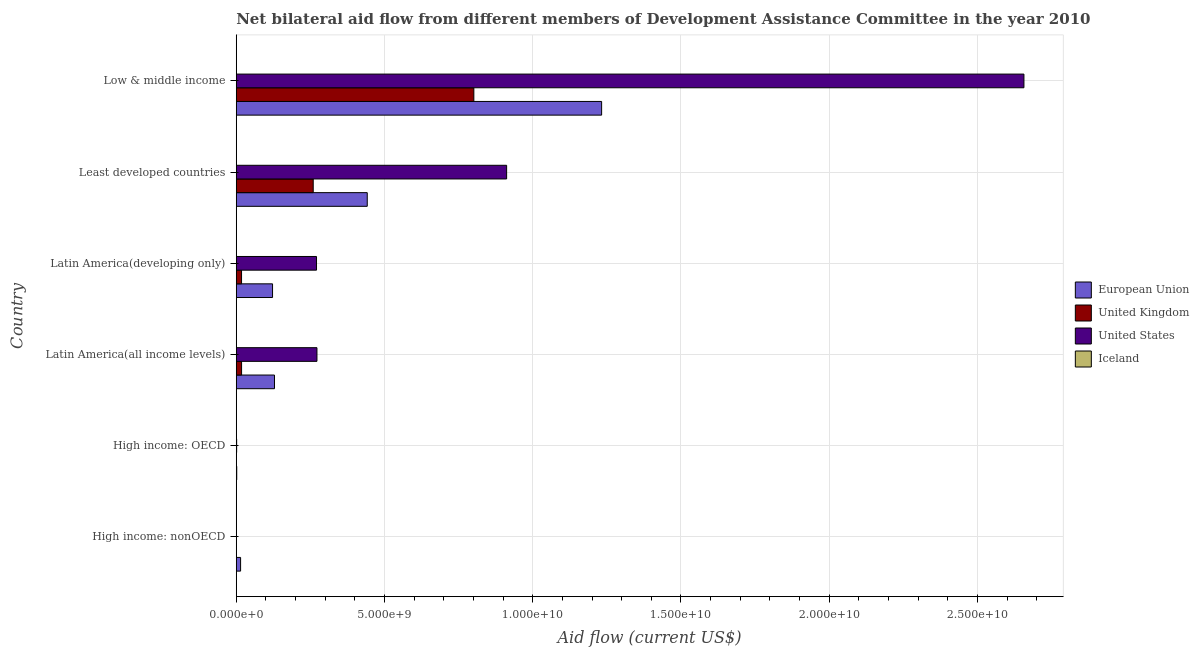How many bars are there on the 2nd tick from the top?
Your answer should be compact. 4. What is the label of the 6th group of bars from the top?
Your answer should be very brief. High income: nonOECD. In how many cases, is the number of bars for a given country not equal to the number of legend labels?
Your answer should be very brief. 0. What is the amount of aid given by us in Least developed countries?
Offer a very short reply. 9.12e+09. Across all countries, what is the maximum amount of aid given by eu?
Keep it short and to the point. 1.23e+1. Across all countries, what is the minimum amount of aid given by uk?
Provide a succinct answer. 6.60e+05. In which country was the amount of aid given by iceland minimum?
Ensure brevity in your answer.  High income: nonOECD. What is the total amount of aid given by eu in the graph?
Your answer should be very brief. 1.94e+1. What is the difference between the amount of aid given by us in High income: nonOECD and that in Low & middle income?
Your answer should be very brief. -2.66e+1. What is the difference between the amount of aid given by eu in Least developed countries and the amount of aid given by us in Latin America(developing only)?
Offer a very short reply. 1.71e+09. What is the average amount of aid given by iceland per country?
Offer a terse response. 2.26e+06. What is the difference between the amount of aid given by iceland and amount of aid given by us in High income: OECD?
Provide a succinct answer. -1.22e+07. What is the ratio of the amount of aid given by iceland in Latin America(developing only) to that in Low & middle income?
Provide a succinct answer. 1.64. Is the difference between the amount of aid given by uk in High income: nonOECD and Least developed countries greater than the difference between the amount of aid given by iceland in High income: nonOECD and Least developed countries?
Give a very brief answer. No. What is the difference between the highest and the second highest amount of aid given by eu?
Your response must be concise. 7.91e+09. What is the difference between the highest and the lowest amount of aid given by us?
Offer a very short reply. 2.66e+1. In how many countries, is the amount of aid given by us greater than the average amount of aid given by us taken over all countries?
Offer a terse response. 2. Is the sum of the amount of aid given by eu in Least developed countries and Low & middle income greater than the maximum amount of aid given by us across all countries?
Offer a terse response. No. Is it the case that in every country, the sum of the amount of aid given by eu and amount of aid given by us is greater than the sum of amount of aid given by iceland and amount of aid given by uk?
Make the answer very short. Yes. What does the 1st bar from the bottom in Low & middle income represents?
Give a very brief answer. European Union. How many bars are there?
Give a very brief answer. 24. How many countries are there in the graph?
Your answer should be compact. 6. Are the values on the major ticks of X-axis written in scientific E-notation?
Your answer should be compact. Yes. Does the graph contain grids?
Make the answer very short. Yes. How many legend labels are there?
Provide a short and direct response. 4. How are the legend labels stacked?
Provide a short and direct response. Vertical. What is the title of the graph?
Give a very brief answer. Net bilateral aid flow from different members of Development Assistance Committee in the year 2010. Does "Methodology assessment" appear as one of the legend labels in the graph?
Provide a short and direct response. No. What is the label or title of the X-axis?
Your answer should be compact. Aid flow (current US$). What is the label or title of the Y-axis?
Give a very brief answer. Country. What is the Aid flow (current US$) of European Union in High income: nonOECD?
Your answer should be very brief. 1.46e+08. What is the Aid flow (current US$) in United Kingdom in High income: nonOECD?
Provide a short and direct response. 2.37e+06. What is the Aid flow (current US$) of United States in High income: nonOECD?
Make the answer very short. 5.04e+06. What is the Aid flow (current US$) of Iceland in High income: nonOECD?
Keep it short and to the point. 1.05e+06. What is the Aid flow (current US$) in European Union in High income: OECD?
Your response must be concise. 1.62e+07. What is the Aid flow (current US$) of United Kingdom in High income: OECD?
Keep it short and to the point. 6.60e+05. What is the Aid flow (current US$) of United States in High income: OECD?
Give a very brief answer. 1.32e+07. What is the Aid flow (current US$) of Iceland in High income: OECD?
Your answer should be very brief. 1.05e+06. What is the Aid flow (current US$) in European Union in Latin America(all income levels)?
Offer a very short reply. 1.29e+09. What is the Aid flow (current US$) of United Kingdom in Latin America(all income levels)?
Ensure brevity in your answer.  1.80e+08. What is the Aid flow (current US$) of United States in Latin America(all income levels)?
Your answer should be very brief. 2.72e+09. What is the Aid flow (current US$) in Iceland in Latin America(all income levels)?
Ensure brevity in your answer.  4.75e+06. What is the Aid flow (current US$) in European Union in Latin America(developing only)?
Provide a succinct answer. 1.22e+09. What is the Aid flow (current US$) of United Kingdom in Latin America(developing only)?
Provide a short and direct response. 1.78e+08. What is the Aid flow (current US$) of United States in Latin America(developing only)?
Keep it short and to the point. 2.71e+09. What is the Aid flow (current US$) in Iceland in Latin America(developing only)?
Keep it short and to the point. 2.57e+06. What is the Aid flow (current US$) in European Union in Least developed countries?
Your answer should be compact. 4.42e+09. What is the Aid flow (current US$) of United Kingdom in Least developed countries?
Provide a short and direct response. 2.60e+09. What is the Aid flow (current US$) in United States in Least developed countries?
Keep it short and to the point. 9.12e+09. What is the Aid flow (current US$) in Iceland in Least developed countries?
Keep it short and to the point. 2.57e+06. What is the Aid flow (current US$) in European Union in Low & middle income?
Give a very brief answer. 1.23e+1. What is the Aid flow (current US$) in United Kingdom in Low & middle income?
Offer a terse response. 8.01e+09. What is the Aid flow (current US$) of United States in Low & middle income?
Ensure brevity in your answer.  2.66e+1. What is the Aid flow (current US$) of Iceland in Low & middle income?
Offer a very short reply. 1.57e+06. Across all countries, what is the maximum Aid flow (current US$) in European Union?
Make the answer very short. 1.23e+1. Across all countries, what is the maximum Aid flow (current US$) in United Kingdom?
Give a very brief answer. 8.01e+09. Across all countries, what is the maximum Aid flow (current US$) in United States?
Your answer should be very brief. 2.66e+1. Across all countries, what is the maximum Aid flow (current US$) of Iceland?
Offer a very short reply. 4.75e+06. Across all countries, what is the minimum Aid flow (current US$) in European Union?
Ensure brevity in your answer.  1.62e+07. Across all countries, what is the minimum Aid flow (current US$) in United Kingdom?
Offer a very short reply. 6.60e+05. Across all countries, what is the minimum Aid flow (current US$) of United States?
Provide a succinct answer. 5.04e+06. Across all countries, what is the minimum Aid flow (current US$) of Iceland?
Give a very brief answer. 1.05e+06. What is the total Aid flow (current US$) in European Union in the graph?
Provide a short and direct response. 1.94e+1. What is the total Aid flow (current US$) of United Kingdom in the graph?
Keep it short and to the point. 1.10e+1. What is the total Aid flow (current US$) of United States in the graph?
Offer a terse response. 4.11e+1. What is the total Aid flow (current US$) in Iceland in the graph?
Keep it short and to the point. 1.36e+07. What is the difference between the Aid flow (current US$) in European Union in High income: nonOECD and that in High income: OECD?
Your response must be concise. 1.30e+08. What is the difference between the Aid flow (current US$) in United Kingdom in High income: nonOECD and that in High income: OECD?
Make the answer very short. 1.71e+06. What is the difference between the Aid flow (current US$) of United States in High income: nonOECD and that in High income: OECD?
Give a very brief answer. -8.21e+06. What is the difference between the Aid flow (current US$) in European Union in High income: nonOECD and that in Latin America(all income levels)?
Give a very brief answer. -1.14e+09. What is the difference between the Aid flow (current US$) in United Kingdom in High income: nonOECD and that in Latin America(all income levels)?
Offer a very short reply. -1.77e+08. What is the difference between the Aid flow (current US$) of United States in High income: nonOECD and that in Latin America(all income levels)?
Give a very brief answer. -2.72e+09. What is the difference between the Aid flow (current US$) in Iceland in High income: nonOECD and that in Latin America(all income levels)?
Your answer should be very brief. -3.70e+06. What is the difference between the Aid flow (current US$) in European Union in High income: nonOECD and that in Latin America(developing only)?
Your answer should be compact. -1.08e+09. What is the difference between the Aid flow (current US$) of United Kingdom in High income: nonOECD and that in Latin America(developing only)?
Your response must be concise. -1.76e+08. What is the difference between the Aid flow (current US$) of United States in High income: nonOECD and that in Latin America(developing only)?
Provide a short and direct response. -2.70e+09. What is the difference between the Aid flow (current US$) of Iceland in High income: nonOECD and that in Latin America(developing only)?
Provide a short and direct response. -1.52e+06. What is the difference between the Aid flow (current US$) in European Union in High income: nonOECD and that in Least developed countries?
Give a very brief answer. -4.27e+09. What is the difference between the Aid flow (current US$) in United Kingdom in High income: nonOECD and that in Least developed countries?
Keep it short and to the point. -2.59e+09. What is the difference between the Aid flow (current US$) in United States in High income: nonOECD and that in Least developed countries?
Ensure brevity in your answer.  -9.11e+09. What is the difference between the Aid flow (current US$) of Iceland in High income: nonOECD and that in Least developed countries?
Keep it short and to the point. -1.52e+06. What is the difference between the Aid flow (current US$) in European Union in High income: nonOECD and that in Low & middle income?
Provide a succinct answer. -1.22e+1. What is the difference between the Aid flow (current US$) of United Kingdom in High income: nonOECD and that in Low & middle income?
Offer a terse response. -8.01e+09. What is the difference between the Aid flow (current US$) in United States in High income: nonOECD and that in Low & middle income?
Keep it short and to the point. -2.66e+1. What is the difference between the Aid flow (current US$) of Iceland in High income: nonOECD and that in Low & middle income?
Offer a terse response. -5.20e+05. What is the difference between the Aid flow (current US$) of European Union in High income: OECD and that in Latin America(all income levels)?
Give a very brief answer. -1.27e+09. What is the difference between the Aid flow (current US$) of United Kingdom in High income: OECD and that in Latin America(all income levels)?
Your answer should be compact. -1.79e+08. What is the difference between the Aid flow (current US$) in United States in High income: OECD and that in Latin America(all income levels)?
Give a very brief answer. -2.71e+09. What is the difference between the Aid flow (current US$) of Iceland in High income: OECD and that in Latin America(all income levels)?
Offer a terse response. -3.70e+06. What is the difference between the Aid flow (current US$) of European Union in High income: OECD and that in Latin America(developing only)?
Provide a short and direct response. -1.21e+09. What is the difference between the Aid flow (current US$) in United Kingdom in High income: OECD and that in Latin America(developing only)?
Your answer should be very brief. -1.78e+08. What is the difference between the Aid flow (current US$) of United States in High income: OECD and that in Latin America(developing only)?
Your answer should be compact. -2.69e+09. What is the difference between the Aid flow (current US$) in Iceland in High income: OECD and that in Latin America(developing only)?
Keep it short and to the point. -1.52e+06. What is the difference between the Aid flow (current US$) in European Union in High income: OECD and that in Least developed countries?
Your response must be concise. -4.40e+09. What is the difference between the Aid flow (current US$) in United Kingdom in High income: OECD and that in Least developed countries?
Give a very brief answer. -2.60e+09. What is the difference between the Aid flow (current US$) of United States in High income: OECD and that in Least developed countries?
Your response must be concise. -9.11e+09. What is the difference between the Aid flow (current US$) of Iceland in High income: OECD and that in Least developed countries?
Make the answer very short. -1.52e+06. What is the difference between the Aid flow (current US$) of European Union in High income: OECD and that in Low & middle income?
Your response must be concise. -1.23e+1. What is the difference between the Aid flow (current US$) in United Kingdom in High income: OECD and that in Low & middle income?
Ensure brevity in your answer.  -8.01e+09. What is the difference between the Aid flow (current US$) of United States in High income: OECD and that in Low & middle income?
Offer a terse response. -2.66e+1. What is the difference between the Aid flow (current US$) in Iceland in High income: OECD and that in Low & middle income?
Your response must be concise. -5.20e+05. What is the difference between the Aid flow (current US$) of European Union in Latin America(all income levels) and that in Latin America(developing only)?
Offer a very short reply. 6.52e+07. What is the difference between the Aid flow (current US$) in United Kingdom in Latin America(all income levels) and that in Latin America(developing only)?
Provide a short and direct response. 1.14e+06. What is the difference between the Aid flow (current US$) of United States in Latin America(all income levels) and that in Latin America(developing only)?
Provide a succinct answer. 1.50e+07. What is the difference between the Aid flow (current US$) of Iceland in Latin America(all income levels) and that in Latin America(developing only)?
Provide a short and direct response. 2.18e+06. What is the difference between the Aid flow (current US$) in European Union in Latin America(all income levels) and that in Least developed countries?
Your answer should be very brief. -3.13e+09. What is the difference between the Aid flow (current US$) of United Kingdom in Latin America(all income levels) and that in Least developed countries?
Ensure brevity in your answer.  -2.42e+09. What is the difference between the Aid flow (current US$) of United States in Latin America(all income levels) and that in Least developed countries?
Keep it short and to the point. -6.40e+09. What is the difference between the Aid flow (current US$) of Iceland in Latin America(all income levels) and that in Least developed countries?
Make the answer very short. 2.18e+06. What is the difference between the Aid flow (current US$) of European Union in Latin America(all income levels) and that in Low & middle income?
Make the answer very short. -1.10e+1. What is the difference between the Aid flow (current US$) of United Kingdom in Latin America(all income levels) and that in Low & middle income?
Your answer should be compact. -7.83e+09. What is the difference between the Aid flow (current US$) in United States in Latin America(all income levels) and that in Low & middle income?
Your answer should be compact. -2.38e+1. What is the difference between the Aid flow (current US$) in Iceland in Latin America(all income levels) and that in Low & middle income?
Ensure brevity in your answer.  3.18e+06. What is the difference between the Aid flow (current US$) in European Union in Latin America(developing only) and that in Least developed countries?
Provide a short and direct response. -3.19e+09. What is the difference between the Aid flow (current US$) in United Kingdom in Latin America(developing only) and that in Least developed countries?
Ensure brevity in your answer.  -2.42e+09. What is the difference between the Aid flow (current US$) of United States in Latin America(developing only) and that in Least developed countries?
Offer a very short reply. -6.41e+09. What is the difference between the Aid flow (current US$) of European Union in Latin America(developing only) and that in Low & middle income?
Offer a very short reply. -1.11e+1. What is the difference between the Aid flow (current US$) of United Kingdom in Latin America(developing only) and that in Low & middle income?
Provide a short and direct response. -7.84e+09. What is the difference between the Aid flow (current US$) of United States in Latin America(developing only) and that in Low & middle income?
Keep it short and to the point. -2.39e+1. What is the difference between the Aid flow (current US$) in European Union in Least developed countries and that in Low & middle income?
Provide a succinct answer. -7.91e+09. What is the difference between the Aid flow (current US$) of United Kingdom in Least developed countries and that in Low & middle income?
Offer a very short reply. -5.42e+09. What is the difference between the Aid flow (current US$) of United States in Least developed countries and that in Low & middle income?
Your answer should be very brief. -1.74e+1. What is the difference between the Aid flow (current US$) of European Union in High income: nonOECD and the Aid flow (current US$) of United Kingdom in High income: OECD?
Your response must be concise. 1.46e+08. What is the difference between the Aid flow (current US$) of European Union in High income: nonOECD and the Aid flow (current US$) of United States in High income: OECD?
Keep it short and to the point. 1.33e+08. What is the difference between the Aid flow (current US$) in European Union in High income: nonOECD and the Aid flow (current US$) in Iceland in High income: OECD?
Your answer should be very brief. 1.45e+08. What is the difference between the Aid flow (current US$) in United Kingdom in High income: nonOECD and the Aid flow (current US$) in United States in High income: OECD?
Offer a very short reply. -1.09e+07. What is the difference between the Aid flow (current US$) in United Kingdom in High income: nonOECD and the Aid flow (current US$) in Iceland in High income: OECD?
Provide a short and direct response. 1.32e+06. What is the difference between the Aid flow (current US$) of United States in High income: nonOECD and the Aid flow (current US$) of Iceland in High income: OECD?
Your answer should be compact. 3.99e+06. What is the difference between the Aid flow (current US$) of European Union in High income: nonOECD and the Aid flow (current US$) of United Kingdom in Latin America(all income levels)?
Ensure brevity in your answer.  -3.31e+07. What is the difference between the Aid flow (current US$) in European Union in High income: nonOECD and the Aid flow (current US$) in United States in Latin America(all income levels)?
Provide a short and direct response. -2.58e+09. What is the difference between the Aid flow (current US$) in European Union in High income: nonOECD and the Aid flow (current US$) in Iceland in Latin America(all income levels)?
Provide a succinct answer. 1.42e+08. What is the difference between the Aid flow (current US$) of United Kingdom in High income: nonOECD and the Aid flow (current US$) of United States in Latin America(all income levels)?
Your answer should be very brief. -2.72e+09. What is the difference between the Aid flow (current US$) of United Kingdom in High income: nonOECD and the Aid flow (current US$) of Iceland in Latin America(all income levels)?
Offer a very short reply. -2.38e+06. What is the difference between the Aid flow (current US$) of United States in High income: nonOECD and the Aid flow (current US$) of Iceland in Latin America(all income levels)?
Offer a terse response. 2.90e+05. What is the difference between the Aid flow (current US$) of European Union in High income: nonOECD and the Aid flow (current US$) of United Kingdom in Latin America(developing only)?
Your answer should be very brief. -3.20e+07. What is the difference between the Aid flow (current US$) in European Union in High income: nonOECD and the Aid flow (current US$) in United States in Latin America(developing only)?
Your answer should be compact. -2.56e+09. What is the difference between the Aid flow (current US$) in European Union in High income: nonOECD and the Aid flow (current US$) in Iceland in Latin America(developing only)?
Provide a succinct answer. 1.44e+08. What is the difference between the Aid flow (current US$) in United Kingdom in High income: nonOECD and the Aid flow (current US$) in United States in Latin America(developing only)?
Ensure brevity in your answer.  -2.70e+09. What is the difference between the Aid flow (current US$) of United States in High income: nonOECD and the Aid flow (current US$) of Iceland in Latin America(developing only)?
Your answer should be very brief. 2.47e+06. What is the difference between the Aid flow (current US$) in European Union in High income: nonOECD and the Aid flow (current US$) in United Kingdom in Least developed countries?
Offer a terse response. -2.45e+09. What is the difference between the Aid flow (current US$) of European Union in High income: nonOECD and the Aid flow (current US$) of United States in Least developed countries?
Your answer should be compact. -8.97e+09. What is the difference between the Aid flow (current US$) of European Union in High income: nonOECD and the Aid flow (current US$) of Iceland in Least developed countries?
Your answer should be compact. 1.44e+08. What is the difference between the Aid flow (current US$) of United Kingdom in High income: nonOECD and the Aid flow (current US$) of United States in Least developed countries?
Offer a terse response. -9.12e+09. What is the difference between the Aid flow (current US$) of United States in High income: nonOECD and the Aid flow (current US$) of Iceland in Least developed countries?
Keep it short and to the point. 2.47e+06. What is the difference between the Aid flow (current US$) of European Union in High income: nonOECD and the Aid flow (current US$) of United Kingdom in Low & middle income?
Your answer should be very brief. -7.87e+09. What is the difference between the Aid flow (current US$) of European Union in High income: nonOECD and the Aid flow (current US$) of United States in Low & middle income?
Provide a short and direct response. -2.64e+1. What is the difference between the Aid flow (current US$) in European Union in High income: nonOECD and the Aid flow (current US$) in Iceland in Low & middle income?
Your answer should be very brief. 1.45e+08. What is the difference between the Aid flow (current US$) of United Kingdom in High income: nonOECD and the Aid flow (current US$) of United States in Low & middle income?
Ensure brevity in your answer.  -2.66e+1. What is the difference between the Aid flow (current US$) of United States in High income: nonOECD and the Aid flow (current US$) of Iceland in Low & middle income?
Your response must be concise. 3.47e+06. What is the difference between the Aid flow (current US$) in European Union in High income: OECD and the Aid flow (current US$) in United Kingdom in Latin America(all income levels)?
Keep it short and to the point. -1.63e+08. What is the difference between the Aid flow (current US$) in European Union in High income: OECD and the Aid flow (current US$) in United States in Latin America(all income levels)?
Provide a succinct answer. -2.71e+09. What is the difference between the Aid flow (current US$) of European Union in High income: OECD and the Aid flow (current US$) of Iceland in Latin America(all income levels)?
Give a very brief answer. 1.14e+07. What is the difference between the Aid flow (current US$) in United Kingdom in High income: OECD and the Aid flow (current US$) in United States in Latin America(all income levels)?
Provide a short and direct response. -2.72e+09. What is the difference between the Aid flow (current US$) of United Kingdom in High income: OECD and the Aid flow (current US$) of Iceland in Latin America(all income levels)?
Keep it short and to the point. -4.09e+06. What is the difference between the Aid flow (current US$) of United States in High income: OECD and the Aid flow (current US$) of Iceland in Latin America(all income levels)?
Your answer should be very brief. 8.50e+06. What is the difference between the Aid flow (current US$) in European Union in High income: OECD and the Aid flow (current US$) in United Kingdom in Latin America(developing only)?
Keep it short and to the point. -1.62e+08. What is the difference between the Aid flow (current US$) in European Union in High income: OECD and the Aid flow (current US$) in United States in Latin America(developing only)?
Provide a short and direct response. -2.69e+09. What is the difference between the Aid flow (current US$) of European Union in High income: OECD and the Aid flow (current US$) of Iceland in Latin America(developing only)?
Your answer should be very brief. 1.36e+07. What is the difference between the Aid flow (current US$) in United Kingdom in High income: OECD and the Aid flow (current US$) in United States in Latin America(developing only)?
Keep it short and to the point. -2.71e+09. What is the difference between the Aid flow (current US$) in United Kingdom in High income: OECD and the Aid flow (current US$) in Iceland in Latin America(developing only)?
Keep it short and to the point. -1.91e+06. What is the difference between the Aid flow (current US$) in United States in High income: OECD and the Aid flow (current US$) in Iceland in Latin America(developing only)?
Your answer should be very brief. 1.07e+07. What is the difference between the Aid flow (current US$) in European Union in High income: OECD and the Aid flow (current US$) in United Kingdom in Least developed countries?
Your answer should be compact. -2.58e+09. What is the difference between the Aid flow (current US$) in European Union in High income: OECD and the Aid flow (current US$) in United States in Least developed countries?
Offer a very short reply. -9.10e+09. What is the difference between the Aid flow (current US$) in European Union in High income: OECD and the Aid flow (current US$) in Iceland in Least developed countries?
Provide a succinct answer. 1.36e+07. What is the difference between the Aid flow (current US$) in United Kingdom in High income: OECD and the Aid flow (current US$) in United States in Least developed countries?
Your answer should be very brief. -9.12e+09. What is the difference between the Aid flow (current US$) in United Kingdom in High income: OECD and the Aid flow (current US$) in Iceland in Least developed countries?
Your answer should be very brief. -1.91e+06. What is the difference between the Aid flow (current US$) of United States in High income: OECD and the Aid flow (current US$) of Iceland in Least developed countries?
Offer a very short reply. 1.07e+07. What is the difference between the Aid flow (current US$) of European Union in High income: OECD and the Aid flow (current US$) of United Kingdom in Low & middle income?
Offer a very short reply. -8.00e+09. What is the difference between the Aid flow (current US$) of European Union in High income: OECD and the Aid flow (current US$) of United States in Low & middle income?
Your answer should be compact. -2.66e+1. What is the difference between the Aid flow (current US$) of European Union in High income: OECD and the Aid flow (current US$) of Iceland in Low & middle income?
Offer a terse response. 1.46e+07. What is the difference between the Aid flow (current US$) of United Kingdom in High income: OECD and the Aid flow (current US$) of United States in Low & middle income?
Your answer should be compact. -2.66e+1. What is the difference between the Aid flow (current US$) of United Kingdom in High income: OECD and the Aid flow (current US$) of Iceland in Low & middle income?
Offer a terse response. -9.10e+05. What is the difference between the Aid flow (current US$) of United States in High income: OECD and the Aid flow (current US$) of Iceland in Low & middle income?
Provide a short and direct response. 1.17e+07. What is the difference between the Aid flow (current US$) in European Union in Latin America(all income levels) and the Aid flow (current US$) in United Kingdom in Latin America(developing only)?
Your response must be concise. 1.11e+09. What is the difference between the Aid flow (current US$) in European Union in Latin America(all income levels) and the Aid flow (current US$) in United States in Latin America(developing only)?
Make the answer very short. -1.42e+09. What is the difference between the Aid flow (current US$) of European Union in Latin America(all income levels) and the Aid flow (current US$) of Iceland in Latin America(developing only)?
Ensure brevity in your answer.  1.29e+09. What is the difference between the Aid flow (current US$) of United Kingdom in Latin America(all income levels) and the Aid flow (current US$) of United States in Latin America(developing only)?
Provide a succinct answer. -2.53e+09. What is the difference between the Aid flow (current US$) in United Kingdom in Latin America(all income levels) and the Aid flow (current US$) in Iceland in Latin America(developing only)?
Offer a terse response. 1.77e+08. What is the difference between the Aid flow (current US$) of United States in Latin America(all income levels) and the Aid flow (current US$) of Iceland in Latin America(developing only)?
Provide a succinct answer. 2.72e+09. What is the difference between the Aid flow (current US$) in European Union in Latin America(all income levels) and the Aid flow (current US$) in United Kingdom in Least developed countries?
Provide a short and direct response. -1.31e+09. What is the difference between the Aid flow (current US$) of European Union in Latin America(all income levels) and the Aid flow (current US$) of United States in Least developed countries?
Provide a succinct answer. -7.83e+09. What is the difference between the Aid flow (current US$) of European Union in Latin America(all income levels) and the Aid flow (current US$) of Iceland in Least developed countries?
Your answer should be very brief. 1.29e+09. What is the difference between the Aid flow (current US$) of United Kingdom in Latin America(all income levels) and the Aid flow (current US$) of United States in Least developed countries?
Give a very brief answer. -8.94e+09. What is the difference between the Aid flow (current US$) of United Kingdom in Latin America(all income levels) and the Aid flow (current US$) of Iceland in Least developed countries?
Provide a succinct answer. 1.77e+08. What is the difference between the Aid flow (current US$) of United States in Latin America(all income levels) and the Aid flow (current US$) of Iceland in Least developed countries?
Your answer should be compact. 2.72e+09. What is the difference between the Aid flow (current US$) in European Union in Latin America(all income levels) and the Aid flow (current US$) in United Kingdom in Low & middle income?
Offer a very short reply. -6.72e+09. What is the difference between the Aid flow (current US$) of European Union in Latin America(all income levels) and the Aid flow (current US$) of United States in Low & middle income?
Your answer should be compact. -2.53e+1. What is the difference between the Aid flow (current US$) of European Union in Latin America(all income levels) and the Aid flow (current US$) of Iceland in Low & middle income?
Ensure brevity in your answer.  1.29e+09. What is the difference between the Aid flow (current US$) of United Kingdom in Latin America(all income levels) and the Aid flow (current US$) of United States in Low & middle income?
Make the answer very short. -2.64e+1. What is the difference between the Aid flow (current US$) in United Kingdom in Latin America(all income levels) and the Aid flow (current US$) in Iceland in Low & middle income?
Provide a short and direct response. 1.78e+08. What is the difference between the Aid flow (current US$) of United States in Latin America(all income levels) and the Aid flow (current US$) of Iceland in Low & middle income?
Provide a succinct answer. 2.72e+09. What is the difference between the Aid flow (current US$) in European Union in Latin America(developing only) and the Aid flow (current US$) in United Kingdom in Least developed countries?
Keep it short and to the point. -1.37e+09. What is the difference between the Aid flow (current US$) in European Union in Latin America(developing only) and the Aid flow (current US$) in United States in Least developed countries?
Ensure brevity in your answer.  -7.90e+09. What is the difference between the Aid flow (current US$) in European Union in Latin America(developing only) and the Aid flow (current US$) in Iceland in Least developed countries?
Provide a succinct answer. 1.22e+09. What is the difference between the Aid flow (current US$) of United Kingdom in Latin America(developing only) and the Aid flow (current US$) of United States in Least developed countries?
Provide a succinct answer. -8.94e+09. What is the difference between the Aid flow (current US$) in United Kingdom in Latin America(developing only) and the Aid flow (current US$) in Iceland in Least developed countries?
Give a very brief answer. 1.76e+08. What is the difference between the Aid flow (current US$) of United States in Latin America(developing only) and the Aid flow (current US$) of Iceland in Least developed countries?
Your answer should be very brief. 2.70e+09. What is the difference between the Aid flow (current US$) of European Union in Latin America(developing only) and the Aid flow (current US$) of United Kingdom in Low & middle income?
Your response must be concise. -6.79e+09. What is the difference between the Aid flow (current US$) in European Union in Latin America(developing only) and the Aid flow (current US$) in United States in Low & middle income?
Offer a very short reply. -2.53e+1. What is the difference between the Aid flow (current US$) of European Union in Latin America(developing only) and the Aid flow (current US$) of Iceland in Low & middle income?
Provide a succinct answer. 1.22e+09. What is the difference between the Aid flow (current US$) in United Kingdom in Latin America(developing only) and the Aid flow (current US$) in United States in Low & middle income?
Your response must be concise. -2.64e+1. What is the difference between the Aid flow (current US$) of United Kingdom in Latin America(developing only) and the Aid flow (current US$) of Iceland in Low & middle income?
Your response must be concise. 1.77e+08. What is the difference between the Aid flow (current US$) of United States in Latin America(developing only) and the Aid flow (current US$) of Iceland in Low & middle income?
Give a very brief answer. 2.71e+09. What is the difference between the Aid flow (current US$) of European Union in Least developed countries and the Aid flow (current US$) of United Kingdom in Low & middle income?
Your answer should be compact. -3.60e+09. What is the difference between the Aid flow (current US$) in European Union in Least developed countries and the Aid flow (current US$) in United States in Low & middle income?
Your answer should be compact. -2.21e+1. What is the difference between the Aid flow (current US$) of European Union in Least developed countries and the Aid flow (current US$) of Iceland in Low & middle income?
Offer a terse response. 4.42e+09. What is the difference between the Aid flow (current US$) in United Kingdom in Least developed countries and the Aid flow (current US$) in United States in Low & middle income?
Make the answer very short. -2.40e+1. What is the difference between the Aid flow (current US$) of United Kingdom in Least developed countries and the Aid flow (current US$) of Iceland in Low & middle income?
Ensure brevity in your answer.  2.59e+09. What is the difference between the Aid flow (current US$) in United States in Least developed countries and the Aid flow (current US$) in Iceland in Low & middle income?
Make the answer very short. 9.12e+09. What is the average Aid flow (current US$) in European Union per country?
Your response must be concise. 3.24e+09. What is the average Aid flow (current US$) in United Kingdom per country?
Give a very brief answer. 1.83e+09. What is the average Aid flow (current US$) in United States per country?
Keep it short and to the point. 6.86e+09. What is the average Aid flow (current US$) of Iceland per country?
Your answer should be compact. 2.26e+06. What is the difference between the Aid flow (current US$) in European Union and Aid flow (current US$) in United Kingdom in High income: nonOECD?
Provide a short and direct response. 1.44e+08. What is the difference between the Aid flow (current US$) of European Union and Aid flow (current US$) of United States in High income: nonOECD?
Keep it short and to the point. 1.41e+08. What is the difference between the Aid flow (current US$) of European Union and Aid flow (current US$) of Iceland in High income: nonOECD?
Your answer should be compact. 1.45e+08. What is the difference between the Aid flow (current US$) of United Kingdom and Aid flow (current US$) of United States in High income: nonOECD?
Ensure brevity in your answer.  -2.67e+06. What is the difference between the Aid flow (current US$) of United Kingdom and Aid flow (current US$) of Iceland in High income: nonOECD?
Offer a terse response. 1.32e+06. What is the difference between the Aid flow (current US$) in United States and Aid flow (current US$) in Iceland in High income: nonOECD?
Your response must be concise. 3.99e+06. What is the difference between the Aid flow (current US$) in European Union and Aid flow (current US$) in United Kingdom in High income: OECD?
Your response must be concise. 1.55e+07. What is the difference between the Aid flow (current US$) in European Union and Aid flow (current US$) in United States in High income: OECD?
Your answer should be compact. 2.90e+06. What is the difference between the Aid flow (current US$) in European Union and Aid flow (current US$) in Iceland in High income: OECD?
Keep it short and to the point. 1.51e+07. What is the difference between the Aid flow (current US$) in United Kingdom and Aid flow (current US$) in United States in High income: OECD?
Provide a short and direct response. -1.26e+07. What is the difference between the Aid flow (current US$) in United Kingdom and Aid flow (current US$) in Iceland in High income: OECD?
Ensure brevity in your answer.  -3.90e+05. What is the difference between the Aid flow (current US$) of United States and Aid flow (current US$) of Iceland in High income: OECD?
Keep it short and to the point. 1.22e+07. What is the difference between the Aid flow (current US$) in European Union and Aid flow (current US$) in United Kingdom in Latin America(all income levels)?
Your answer should be compact. 1.11e+09. What is the difference between the Aid flow (current US$) in European Union and Aid flow (current US$) in United States in Latin America(all income levels)?
Your answer should be very brief. -1.43e+09. What is the difference between the Aid flow (current US$) in European Union and Aid flow (current US$) in Iceland in Latin America(all income levels)?
Make the answer very short. 1.28e+09. What is the difference between the Aid flow (current US$) in United Kingdom and Aid flow (current US$) in United States in Latin America(all income levels)?
Your answer should be compact. -2.54e+09. What is the difference between the Aid flow (current US$) in United Kingdom and Aid flow (current US$) in Iceland in Latin America(all income levels)?
Ensure brevity in your answer.  1.75e+08. What is the difference between the Aid flow (current US$) of United States and Aid flow (current US$) of Iceland in Latin America(all income levels)?
Ensure brevity in your answer.  2.72e+09. What is the difference between the Aid flow (current US$) in European Union and Aid flow (current US$) in United Kingdom in Latin America(developing only)?
Ensure brevity in your answer.  1.05e+09. What is the difference between the Aid flow (current US$) of European Union and Aid flow (current US$) of United States in Latin America(developing only)?
Your answer should be very brief. -1.48e+09. What is the difference between the Aid flow (current US$) in European Union and Aid flow (current US$) in Iceland in Latin America(developing only)?
Your answer should be very brief. 1.22e+09. What is the difference between the Aid flow (current US$) in United Kingdom and Aid flow (current US$) in United States in Latin America(developing only)?
Your answer should be very brief. -2.53e+09. What is the difference between the Aid flow (current US$) of United Kingdom and Aid flow (current US$) of Iceland in Latin America(developing only)?
Offer a terse response. 1.76e+08. What is the difference between the Aid flow (current US$) in United States and Aid flow (current US$) in Iceland in Latin America(developing only)?
Your response must be concise. 2.70e+09. What is the difference between the Aid flow (current US$) of European Union and Aid flow (current US$) of United Kingdom in Least developed countries?
Offer a very short reply. 1.82e+09. What is the difference between the Aid flow (current US$) in European Union and Aid flow (current US$) in United States in Least developed countries?
Offer a terse response. -4.70e+09. What is the difference between the Aid flow (current US$) of European Union and Aid flow (current US$) of Iceland in Least developed countries?
Keep it short and to the point. 4.42e+09. What is the difference between the Aid flow (current US$) in United Kingdom and Aid flow (current US$) in United States in Least developed countries?
Give a very brief answer. -6.52e+09. What is the difference between the Aid flow (current US$) of United Kingdom and Aid flow (current US$) of Iceland in Least developed countries?
Your answer should be very brief. 2.59e+09. What is the difference between the Aid flow (current US$) of United States and Aid flow (current US$) of Iceland in Least developed countries?
Your answer should be very brief. 9.12e+09. What is the difference between the Aid flow (current US$) in European Union and Aid flow (current US$) in United Kingdom in Low & middle income?
Provide a short and direct response. 4.31e+09. What is the difference between the Aid flow (current US$) of European Union and Aid flow (current US$) of United States in Low & middle income?
Keep it short and to the point. -1.42e+1. What is the difference between the Aid flow (current US$) in European Union and Aid flow (current US$) in Iceland in Low & middle income?
Keep it short and to the point. 1.23e+1. What is the difference between the Aid flow (current US$) in United Kingdom and Aid flow (current US$) in United States in Low & middle income?
Make the answer very short. -1.86e+1. What is the difference between the Aid flow (current US$) in United Kingdom and Aid flow (current US$) in Iceland in Low & middle income?
Keep it short and to the point. 8.01e+09. What is the difference between the Aid flow (current US$) in United States and Aid flow (current US$) in Iceland in Low & middle income?
Ensure brevity in your answer.  2.66e+1. What is the ratio of the Aid flow (current US$) of European Union in High income: nonOECD to that in High income: OECD?
Provide a short and direct response. 9.07. What is the ratio of the Aid flow (current US$) in United Kingdom in High income: nonOECD to that in High income: OECD?
Offer a terse response. 3.59. What is the ratio of the Aid flow (current US$) in United States in High income: nonOECD to that in High income: OECD?
Your answer should be very brief. 0.38. What is the ratio of the Aid flow (current US$) in European Union in High income: nonOECD to that in Latin America(all income levels)?
Your answer should be compact. 0.11. What is the ratio of the Aid flow (current US$) in United Kingdom in High income: nonOECD to that in Latin America(all income levels)?
Offer a terse response. 0.01. What is the ratio of the Aid flow (current US$) in United States in High income: nonOECD to that in Latin America(all income levels)?
Offer a very short reply. 0. What is the ratio of the Aid flow (current US$) of Iceland in High income: nonOECD to that in Latin America(all income levels)?
Your answer should be compact. 0.22. What is the ratio of the Aid flow (current US$) in European Union in High income: nonOECD to that in Latin America(developing only)?
Your answer should be very brief. 0.12. What is the ratio of the Aid flow (current US$) of United Kingdom in High income: nonOECD to that in Latin America(developing only)?
Provide a succinct answer. 0.01. What is the ratio of the Aid flow (current US$) of United States in High income: nonOECD to that in Latin America(developing only)?
Your answer should be very brief. 0. What is the ratio of the Aid flow (current US$) of Iceland in High income: nonOECD to that in Latin America(developing only)?
Provide a short and direct response. 0.41. What is the ratio of the Aid flow (current US$) in European Union in High income: nonOECD to that in Least developed countries?
Offer a terse response. 0.03. What is the ratio of the Aid flow (current US$) of United Kingdom in High income: nonOECD to that in Least developed countries?
Offer a terse response. 0. What is the ratio of the Aid flow (current US$) of United States in High income: nonOECD to that in Least developed countries?
Your response must be concise. 0. What is the ratio of the Aid flow (current US$) in Iceland in High income: nonOECD to that in Least developed countries?
Offer a very short reply. 0.41. What is the ratio of the Aid flow (current US$) of European Union in High income: nonOECD to that in Low & middle income?
Your response must be concise. 0.01. What is the ratio of the Aid flow (current US$) in United Kingdom in High income: nonOECD to that in Low & middle income?
Provide a short and direct response. 0. What is the ratio of the Aid flow (current US$) in United States in High income: nonOECD to that in Low & middle income?
Your answer should be very brief. 0. What is the ratio of the Aid flow (current US$) of Iceland in High income: nonOECD to that in Low & middle income?
Provide a short and direct response. 0.67. What is the ratio of the Aid flow (current US$) in European Union in High income: OECD to that in Latin America(all income levels)?
Your answer should be very brief. 0.01. What is the ratio of the Aid flow (current US$) of United Kingdom in High income: OECD to that in Latin America(all income levels)?
Your answer should be compact. 0. What is the ratio of the Aid flow (current US$) of United States in High income: OECD to that in Latin America(all income levels)?
Your answer should be compact. 0. What is the ratio of the Aid flow (current US$) in Iceland in High income: OECD to that in Latin America(all income levels)?
Offer a terse response. 0.22. What is the ratio of the Aid flow (current US$) in European Union in High income: OECD to that in Latin America(developing only)?
Provide a succinct answer. 0.01. What is the ratio of the Aid flow (current US$) in United Kingdom in High income: OECD to that in Latin America(developing only)?
Offer a terse response. 0. What is the ratio of the Aid flow (current US$) of United States in High income: OECD to that in Latin America(developing only)?
Your response must be concise. 0. What is the ratio of the Aid flow (current US$) in Iceland in High income: OECD to that in Latin America(developing only)?
Your answer should be compact. 0.41. What is the ratio of the Aid flow (current US$) in European Union in High income: OECD to that in Least developed countries?
Your response must be concise. 0. What is the ratio of the Aid flow (current US$) in United Kingdom in High income: OECD to that in Least developed countries?
Your response must be concise. 0. What is the ratio of the Aid flow (current US$) of United States in High income: OECD to that in Least developed countries?
Your answer should be compact. 0. What is the ratio of the Aid flow (current US$) of Iceland in High income: OECD to that in Least developed countries?
Your answer should be very brief. 0.41. What is the ratio of the Aid flow (current US$) of European Union in High income: OECD to that in Low & middle income?
Ensure brevity in your answer.  0. What is the ratio of the Aid flow (current US$) of United Kingdom in High income: OECD to that in Low & middle income?
Ensure brevity in your answer.  0. What is the ratio of the Aid flow (current US$) of Iceland in High income: OECD to that in Low & middle income?
Provide a short and direct response. 0.67. What is the ratio of the Aid flow (current US$) of European Union in Latin America(all income levels) to that in Latin America(developing only)?
Your answer should be very brief. 1.05. What is the ratio of the Aid flow (current US$) in United Kingdom in Latin America(all income levels) to that in Latin America(developing only)?
Your answer should be very brief. 1.01. What is the ratio of the Aid flow (current US$) of United States in Latin America(all income levels) to that in Latin America(developing only)?
Your response must be concise. 1.01. What is the ratio of the Aid flow (current US$) in Iceland in Latin America(all income levels) to that in Latin America(developing only)?
Provide a succinct answer. 1.85. What is the ratio of the Aid flow (current US$) in European Union in Latin America(all income levels) to that in Least developed countries?
Your response must be concise. 0.29. What is the ratio of the Aid flow (current US$) in United Kingdom in Latin America(all income levels) to that in Least developed countries?
Ensure brevity in your answer.  0.07. What is the ratio of the Aid flow (current US$) in United States in Latin America(all income levels) to that in Least developed countries?
Ensure brevity in your answer.  0.3. What is the ratio of the Aid flow (current US$) of Iceland in Latin America(all income levels) to that in Least developed countries?
Provide a succinct answer. 1.85. What is the ratio of the Aid flow (current US$) of European Union in Latin America(all income levels) to that in Low & middle income?
Your answer should be compact. 0.1. What is the ratio of the Aid flow (current US$) of United Kingdom in Latin America(all income levels) to that in Low & middle income?
Offer a terse response. 0.02. What is the ratio of the Aid flow (current US$) of United States in Latin America(all income levels) to that in Low & middle income?
Give a very brief answer. 0.1. What is the ratio of the Aid flow (current US$) of Iceland in Latin America(all income levels) to that in Low & middle income?
Make the answer very short. 3.03. What is the ratio of the Aid flow (current US$) of European Union in Latin America(developing only) to that in Least developed countries?
Keep it short and to the point. 0.28. What is the ratio of the Aid flow (current US$) of United Kingdom in Latin America(developing only) to that in Least developed countries?
Your response must be concise. 0.07. What is the ratio of the Aid flow (current US$) of United States in Latin America(developing only) to that in Least developed countries?
Provide a short and direct response. 0.3. What is the ratio of the Aid flow (current US$) in European Union in Latin America(developing only) to that in Low & middle income?
Provide a short and direct response. 0.1. What is the ratio of the Aid flow (current US$) of United Kingdom in Latin America(developing only) to that in Low & middle income?
Keep it short and to the point. 0.02. What is the ratio of the Aid flow (current US$) in United States in Latin America(developing only) to that in Low & middle income?
Your response must be concise. 0.1. What is the ratio of the Aid flow (current US$) in Iceland in Latin America(developing only) to that in Low & middle income?
Keep it short and to the point. 1.64. What is the ratio of the Aid flow (current US$) of European Union in Least developed countries to that in Low & middle income?
Keep it short and to the point. 0.36. What is the ratio of the Aid flow (current US$) in United Kingdom in Least developed countries to that in Low & middle income?
Your answer should be very brief. 0.32. What is the ratio of the Aid flow (current US$) of United States in Least developed countries to that in Low & middle income?
Your answer should be compact. 0.34. What is the ratio of the Aid flow (current US$) in Iceland in Least developed countries to that in Low & middle income?
Provide a short and direct response. 1.64. What is the difference between the highest and the second highest Aid flow (current US$) in European Union?
Offer a terse response. 7.91e+09. What is the difference between the highest and the second highest Aid flow (current US$) of United Kingdom?
Offer a terse response. 5.42e+09. What is the difference between the highest and the second highest Aid flow (current US$) in United States?
Provide a succinct answer. 1.74e+1. What is the difference between the highest and the second highest Aid flow (current US$) of Iceland?
Give a very brief answer. 2.18e+06. What is the difference between the highest and the lowest Aid flow (current US$) in European Union?
Your response must be concise. 1.23e+1. What is the difference between the highest and the lowest Aid flow (current US$) in United Kingdom?
Keep it short and to the point. 8.01e+09. What is the difference between the highest and the lowest Aid flow (current US$) of United States?
Your answer should be very brief. 2.66e+1. What is the difference between the highest and the lowest Aid flow (current US$) of Iceland?
Give a very brief answer. 3.70e+06. 